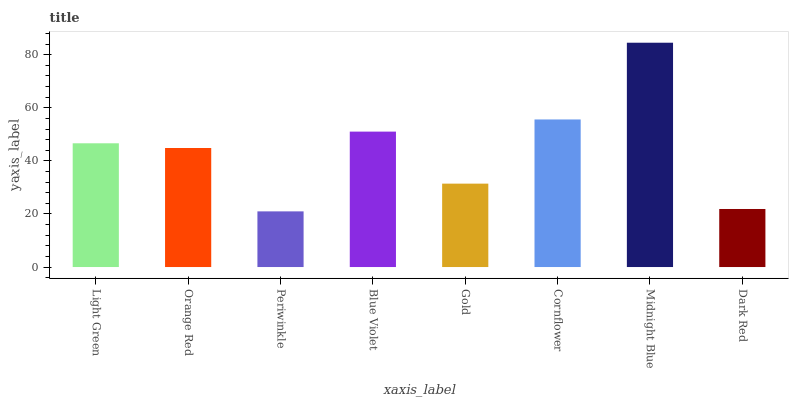Is Periwinkle the minimum?
Answer yes or no. Yes. Is Midnight Blue the maximum?
Answer yes or no. Yes. Is Orange Red the minimum?
Answer yes or no. No. Is Orange Red the maximum?
Answer yes or no. No. Is Light Green greater than Orange Red?
Answer yes or no. Yes. Is Orange Red less than Light Green?
Answer yes or no. Yes. Is Orange Red greater than Light Green?
Answer yes or no. No. Is Light Green less than Orange Red?
Answer yes or no. No. Is Light Green the high median?
Answer yes or no. Yes. Is Orange Red the low median?
Answer yes or no. Yes. Is Cornflower the high median?
Answer yes or no. No. Is Periwinkle the low median?
Answer yes or no. No. 